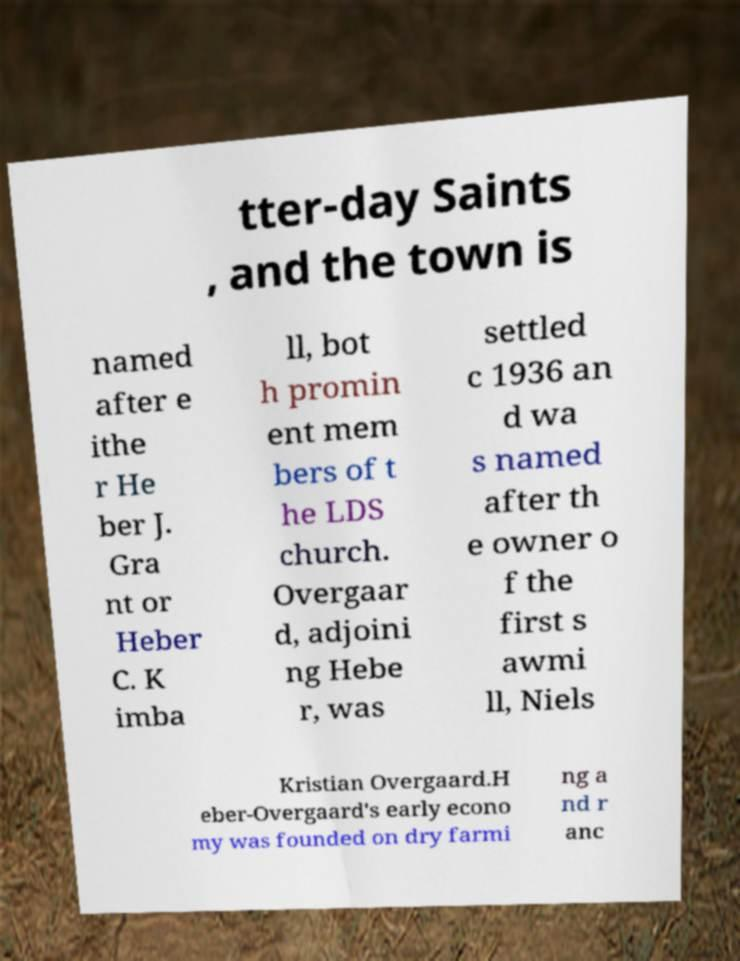I need the written content from this picture converted into text. Can you do that? tter-day Saints , and the town is named after e ithe r He ber J. Gra nt or Heber C. K imba ll, bot h promin ent mem bers of t he LDS church. Overgaar d, adjoini ng Hebe r, was settled c 1936 an d wa s named after th e owner o f the first s awmi ll, Niels Kristian Overgaard.H eber-Overgaard's early econo my was founded on dry farmi ng a nd r anc 